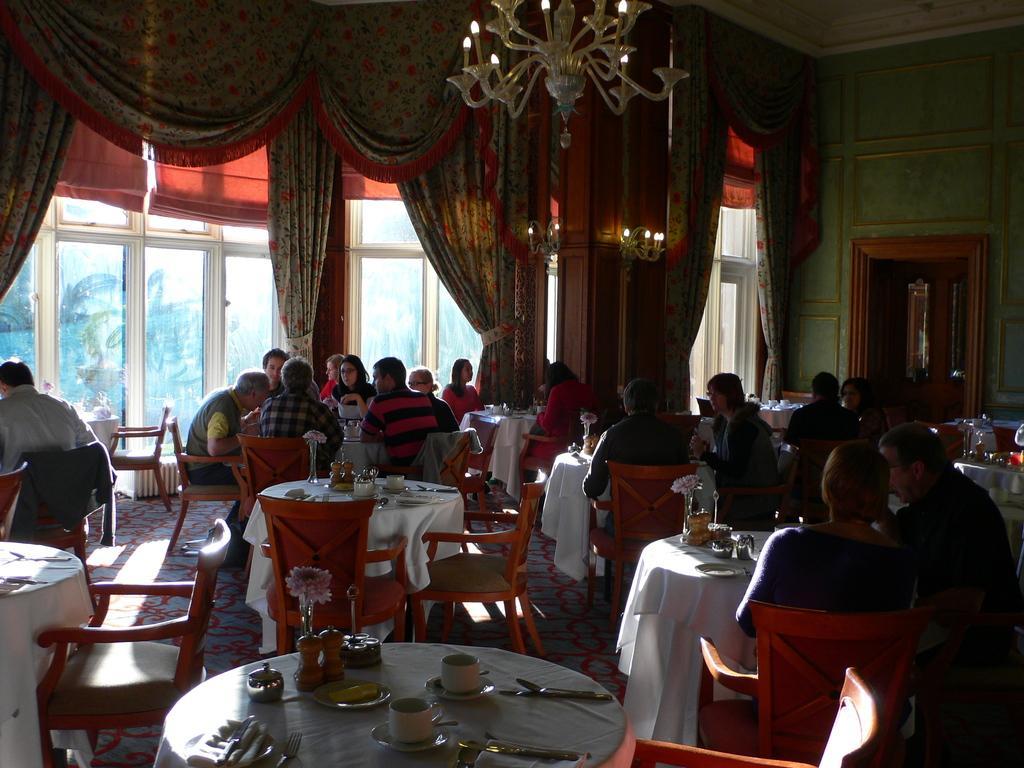Please provide a concise description of this image. Group of people sitting on the chairs. We can see cups,saucers,spoons,flowers,jars on the tables. On the background we can see wall,glass window,curtains. On the top we can see lights. 